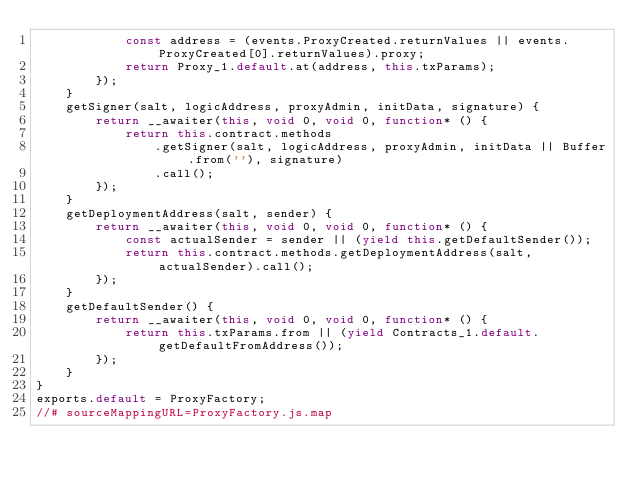<code> <loc_0><loc_0><loc_500><loc_500><_JavaScript_>            const address = (events.ProxyCreated.returnValues || events.ProxyCreated[0].returnValues).proxy;
            return Proxy_1.default.at(address, this.txParams);
        });
    }
    getSigner(salt, logicAddress, proxyAdmin, initData, signature) {
        return __awaiter(this, void 0, void 0, function* () {
            return this.contract.methods
                .getSigner(salt, logicAddress, proxyAdmin, initData || Buffer.from(''), signature)
                .call();
        });
    }
    getDeploymentAddress(salt, sender) {
        return __awaiter(this, void 0, void 0, function* () {
            const actualSender = sender || (yield this.getDefaultSender());
            return this.contract.methods.getDeploymentAddress(salt, actualSender).call();
        });
    }
    getDefaultSender() {
        return __awaiter(this, void 0, void 0, function* () {
            return this.txParams.from || (yield Contracts_1.default.getDefaultFromAddress());
        });
    }
}
exports.default = ProxyFactory;
//# sourceMappingURL=ProxyFactory.js.map</code> 